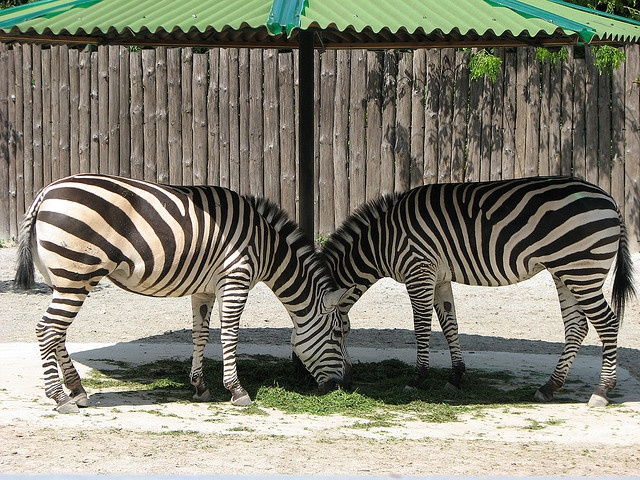Describe the objects in this image and their specific colors. I can see zebra in black, gray, ivory, and darkgray tones, zebra in black, gray, and darkgray tones, and umbrella in black, lightgreen, and darkgray tones in this image. 